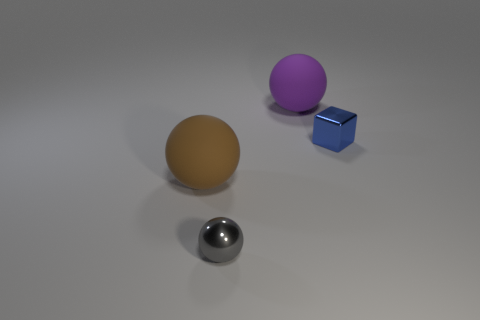Subtract all large spheres. How many spheres are left? 1 Add 4 small metal spheres. How many objects exist? 8 Subtract all spheres. How many objects are left? 1 Subtract all blue spheres. Subtract all brown cubes. How many spheres are left? 3 Subtract all big brown objects. Subtract all large rubber objects. How many objects are left? 1 Add 3 brown rubber spheres. How many brown rubber spheres are left? 4 Add 3 gray metallic objects. How many gray metallic objects exist? 4 Subtract 1 blue cubes. How many objects are left? 3 